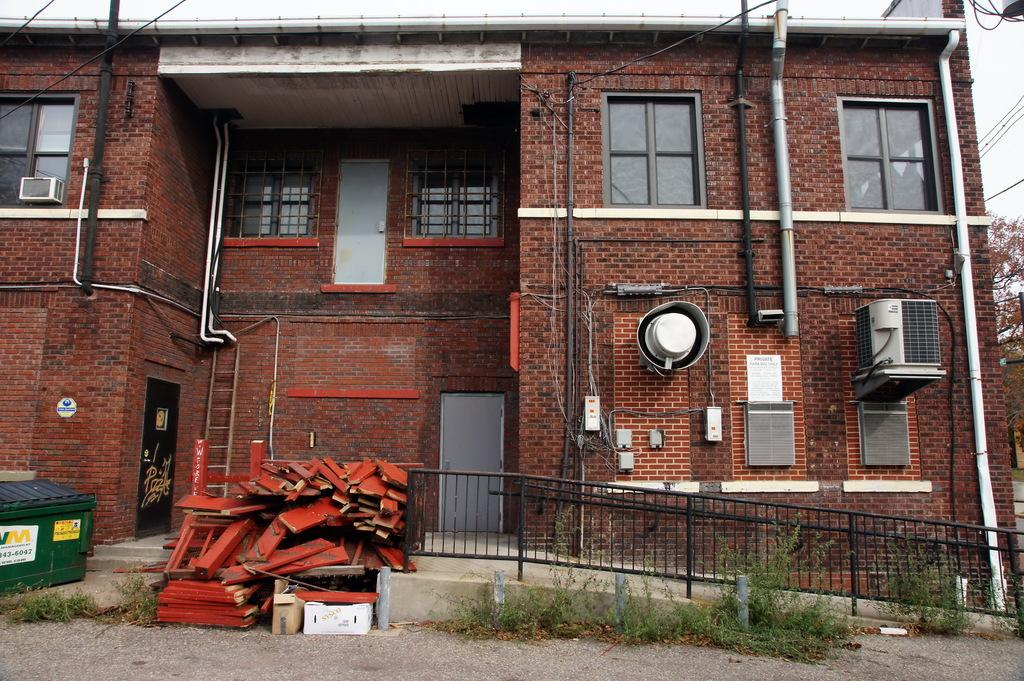What type of barrier is visible in the image? There is a metal fence in the image. What structure can be seen in the background of the image? There is a building in the image. What is located in front of the building? There are objects in front of the building. What type of vegetation is on the right side of the image? There is a tree on the right side of the image. What is the opinion of the tree on the right side of the image? Trees do not have opinions, as they are inanimate objects. How many cats are visible in the image? There are no cats present in the image. 